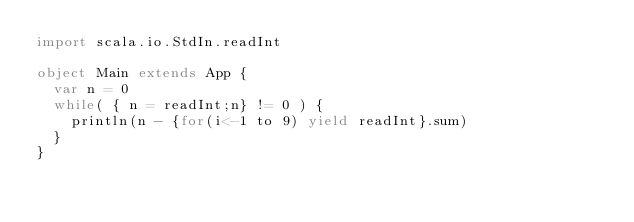<code> <loc_0><loc_0><loc_500><loc_500><_Scala_>import scala.io.StdIn.readInt

object Main extends App {
  var n = 0
  while( { n = readInt;n} != 0 ) {
    println(n - {for(i<-1 to 9) yield readInt}.sum)
  }
}</code> 